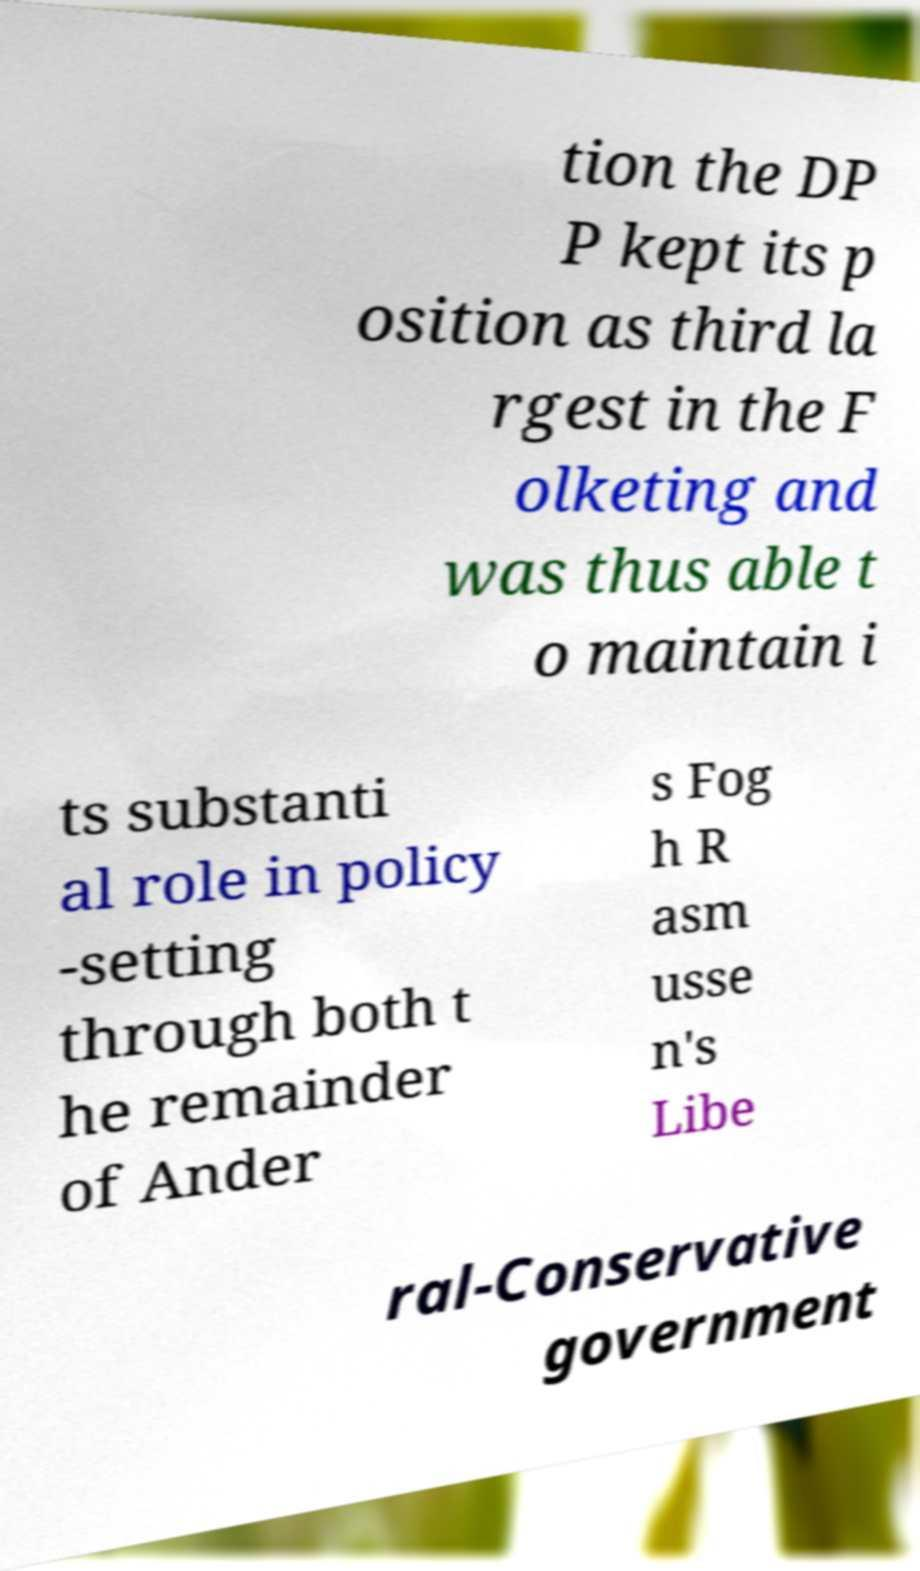I need the written content from this picture converted into text. Can you do that? tion the DP P kept its p osition as third la rgest in the F olketing and was thus able t o maintain i ts substanti al role in policy -setting through both t he remainder of Ander s Fog h R asm usse n's Libe ral-Conservative government 